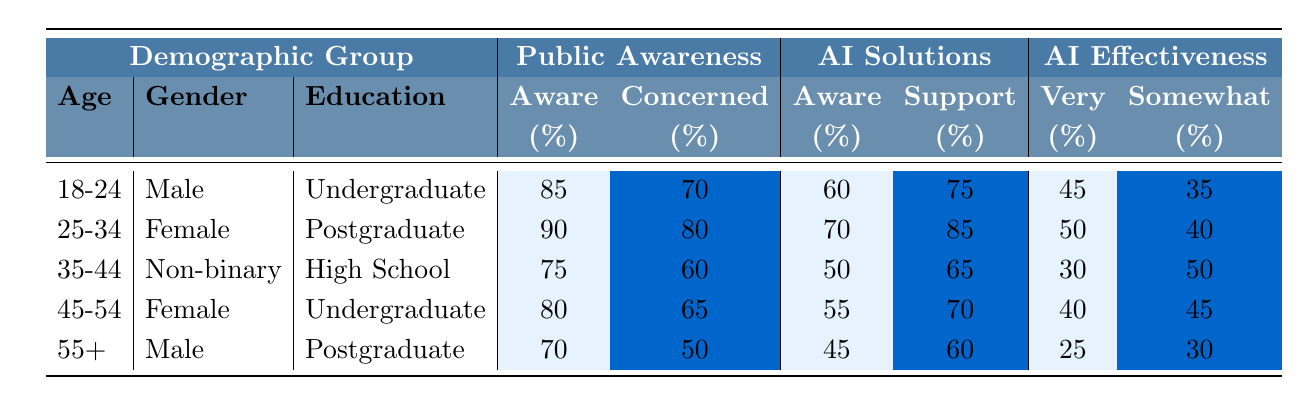What percentage of the 25-34 age group is aware of climate issues? The table shows that for the 25-34 age group, the percentage that is aware of climate issues is 90%.
Answer: 90% What is the percentage of females in the 45-54 age group who support AI solutions? The table indicates that for females in the 45-54 age group, 70% support AI solutions.
Answer: 70% What is the difference in awareness of AI solutions between the 18-24 age group and the 35-44 age group? For the 18-24 age group, 60% are aware of AI solutions, while for the 35-44 age group, 50% are aware. The difference is 60% - 50% = 10%.
Answer: 10% Are individuals in the 55+ age group more concerned about climate issues than those in the 35-44 age group? The 55+ age group has 50% concerned about climate issues, while the 35-44 age group has 60% concerned. Since 50% is less than 60%, the statement is false.
Answer: No What is the average percentage of support for AI solutions across all demographic groups? To find the average, we take the sum of support percentages: (75 + 85 + 65 + 70 + 60) = 355. There are 5 groups, so the average is 355/5 = 71%.
Answer: 71% Which age group has the highest percentage of concern about climate issues and what is that percentage? The highest percentage of concern about climate issues is 80%, found in the 25-34 age group.
Answer: 80% Is there a demographic group that perceives AI solutions as more effective than the 45-54 age group? The 45-54 age group perceives AI solutions as 40% very effective and 45% somewhat effective. The 25-34 age group perceives them as 50% very effective and 40% somewhat effective, indicating that the 25-34 age group views AI solutions as more effective.
Answer: Yes What percentage of the 18-24 age group considers AI solutions to be very effective? According to the table, 45% of the 18-24 age group considers AI solutions to be very effective.
Answer: 45% How many more individuals in the 25-34 age group are concerned about climate issues compared to the 55+ age group? The 25-34 age group has 80% concerned, while the 55+ age group has 50% concerned. The difference is 80% - 50% = 30%.
Answer: 30% Which demographic group has the lowest percentage of awareness of AI solutions, and what is that percentage? The 55+ age group has the lowest awareness of AI solutions at 45%.
Answer: 45% 